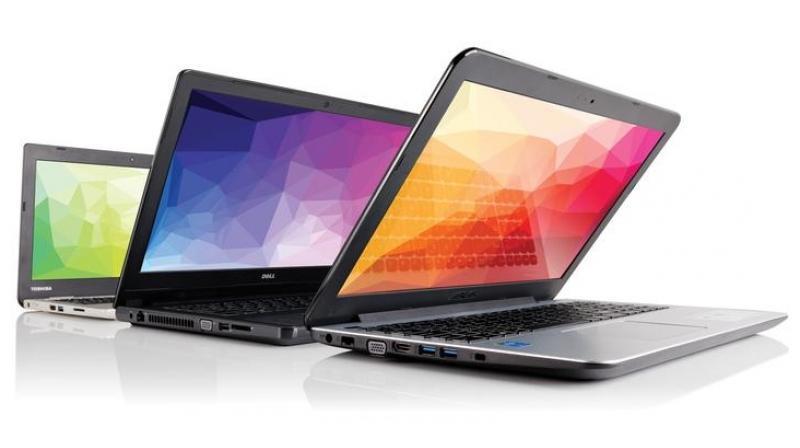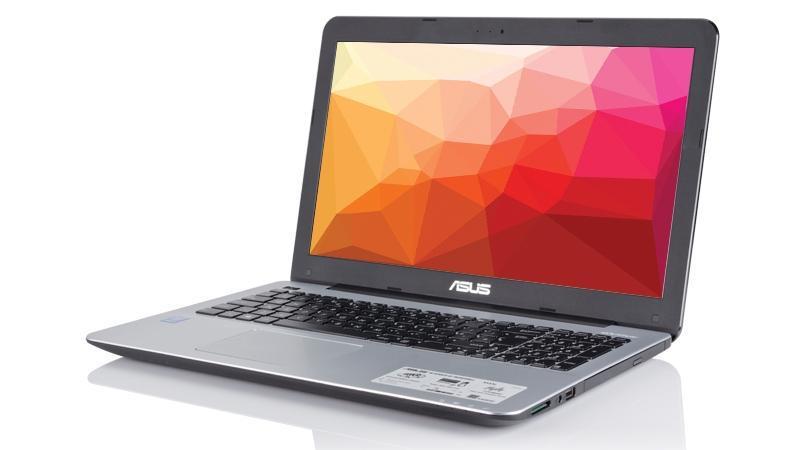The first image is the image on the left, the second image is the image on the right. For the images shown, is this caption "An image shows a back-to-front row of three keyboards with opened screens displaying various bright colors." true? Answer yes or no. Yes. The first image is the image on the left, the second image is the image on the right. For the images shown, is this caption "One laptop is opened up in one of the images." true? Answer yes or no. Yes. 